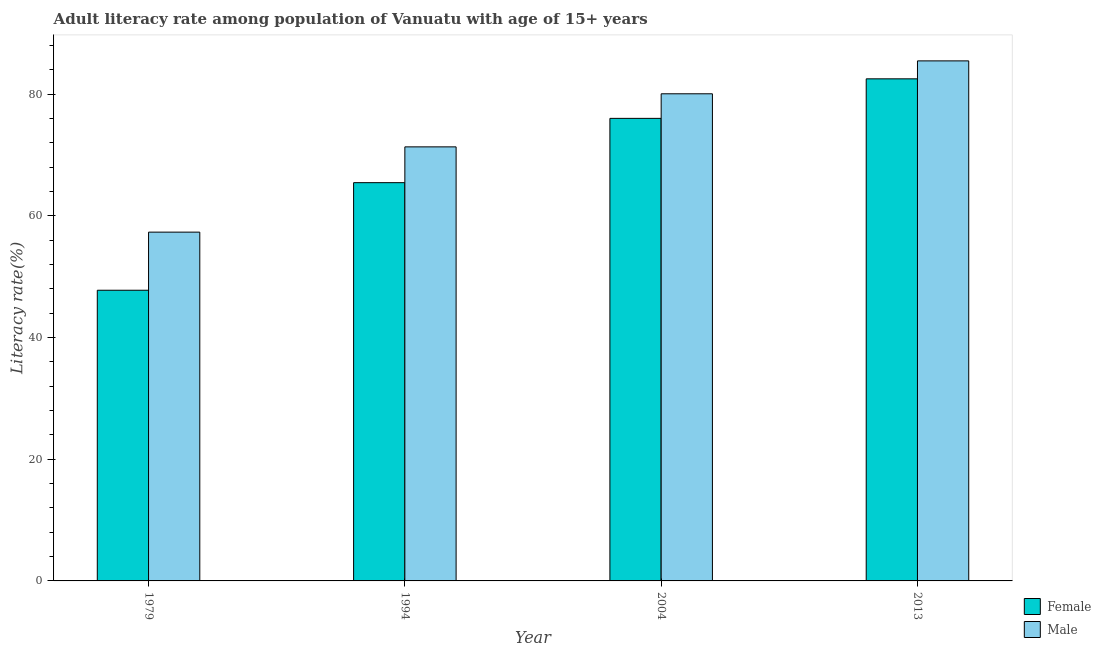How many different coloured bars are there?
Give a very brief answer. 2. How many groups of bars are there?
Your answer should be compact. 4. How many bars are there on the 4th tick from the left?
Your answer should be very brief. 2. What is the label of the 4th group of bars from the left?
Make the answer very short. 2013. What is the female adult literacy rate in 2004?
Provide a short and direct response. 76.03. Across all years, what is the maximum male adult literacy rate?
Offer a terse response. 85.49. Across all years, what is the minimum male adult literacy rate?
Give a very brief answer. 57.34. In which year was the male adult literacy rate minimum?
Give a very brief answer. 1979. What is the total male adult literacy rate in the graph?
Your answer should be very brief. 294.25. What is the difference between the female adult literacy rate in 1979 and that in 2004?
Offer a terse response. -28.25. What is the difference between the female adult literacy rate in 1994 and the male adult literacy rate in 2013?
Ensure brevity in your answer.  -17.07. What is the average female adult literacy rate per year?
Your answer should be compact. 67.95. In the year 2013, what is the difference between the female adult literacy rate and male adult literacy rate?
Offer a terse response. 0. What is the ratio of the male adult literacy rate in 1979 to that in 2013?
Keep it short and to the point. 0.67. Is the difference between the female adult literacy rate in 1994 and 2004 greater than the difference between the male adult literacy rate in 1994 and 2004?
Your response must be concise. No. What is the difference between the highest and the second highest female adult literacy rate?
Your answer should be very brief. 6.5. What is the difference between the highest and the lowest female adult literacy rate?
Keep it short and to the point. 34.75. In how many years, is the female adult literacy rate greater than the average female adult literacy rate taken over all years?
Your response must be concise. 2. How many bars are there?
Ensure brevity in your answer.  8. Are all the bars in the graph horizontal?
Give a very brief answer. No. How many years are there in the graph?
Ensure brevity in your answer.  4. What is the difference between two consecutive major ticks on the Y-axis?
Your answer should be compact. 20. Does the graph contain grids?
Offer a terse response. No. Where does the legend appear in the graph?
Make the answer very short. Bottom right. How many legend labels are there?
Your answer should be very brief. 2. How are the legend labels stacked?
Your answer should be very brief. Vertical. What is the title of the graph?
Provide a succinct answer. Adult literacy rate among population of Vanuatu with age of 15+ years. What is the label or title of the Y-axis?
Your response must be concise. Literacy rate(%). What is the Literacy rate(%) in Female in 1979?
Your answer should be compact. 47.78. What is the Literacy rate(%) in Male in 1979?
Give a very brief answer. 57.34. What is the Literacy rate(%) in Female in 1994?
Your answer should be compact. 65.47. What is the Literacy rate(%) of Male in 1994?
Provide a succinct answer. 71.35. What is the Literacy rate(%) in Female in 2004?
Give a very brief answer. 76.03. What is the Literacy rate(%) in Male in 2004?
Offer a very short reply. 80.07. What is the Literacy rate(%) in Female in 2013?
Ensure brevity in your answer.  82.53. What is the Literacy rate(%) of Male in 2013?
Offer a terse response. 85.49. Across all years, what is the maximum Literacy rate(%) of Female?
Ensure brevity in your answer.  82.53. Across all years, what is the maximum Literacy rate(%) in Male?
Ensure brevity in your answer.  85.49. Across all years, what is the minimum Literacy rate(%) in Female?
Provide a succinct answer. 47.78. Across all years, what is the minimum Literacy rate(%) in Male?
Your answer should be compact. 57.34. What is the total Literacy rate(%) in Female in the graph?
Give a very brief answer. 271.82. What is the total Literacy rate(%) in Male in the graph?
Provide a short and direct response. 294.25. What is the difference between the Literacy rate(%) of Female in 1979 and that in 1994?
Keep it short and to the point. -17.68. What is the difference between the Literacy rate(%) of Male in 1979 and that in 1994?
Make the answer very short. -14.02. What is the difference between the Literacy rate(%) in Female in 1979 and that in 2004?
Provide a succinct answer. -28.25. What is the difference between the Literacy rate(%) in Male in 1979 and that in 2004?
Give a very brief answer. -22.74. What is the difference between the Literacy rate(%) of Female in 1979 and that in 2013?
Offer a terse response. -34.75. What is the difference between the Literacy rate(%) in Male in 1979 and that in 2013?
Keep it short and to the point. -28.15. What is the difference between the Literacy rate(%) in Female in 1994 and that in 2004?
Provide a short and direct response. -10.57. What is the difference between the Literacy rate(%) of Male in 1994 and that in 2004?
Make the answer very short. -8.72. What is the difference between the Literacy rate(%) of Female in 1994 and that in 2013?
Provide a short and direct response. -17.07. What is the difference between the Literacy rate(%) of Male in 1994 and that in 2013?
Give a very brief answer. -14.13. What is the difference between the Literacy rate(%) in Female in 2004 and that in 2013?
Ensure brevity in your answer.  -6.5. What is the difference between the Literacy rate(%) in Male in 2004 and that in 2013?
Your answer should be very brief. -5.41. What is the difference between the Literacy rate(%) of Female in 1979 and the Literacy rate(%) of Male in 1994?
Give a very brief answer. -23.57. What is the difference between the Literacy rate(%) of Female in 1979 and the Literacy rate(%) of Male in 2004?
Ensure brevity in your answer.  -32.29. What is the difference between the Literacy rate(%) of Female in 1979 and the Literacy rate(%) of Male in 2013?
Your answer should be compact. -37.7. What is the difference between the Literacy rate(%) in Female in 1994 and the Literacy rate(%) in Male in 2004?
Offer a terse response. -14.61. What is the difference between the Literacy rate(%) in Female in 1994 and the Literacy rate(%) in Male in 2013?
Your answer should be very brief. -20.02. What is the difference between the Literacy rate(%) of Female in 2004 and the Literacy rate(%) of Male in 2013?
Your response must be concise. -9.45. What is the average Literacy rate(%) of Female per year?
Offer a very short reply. 67.95. What is the average Literacy rate(%) in Male per year?
Provide a short and direct response. 73.56. In the year 1979, what is the difference between the Literacy rate(%) in Female and Literacy rate(%) in Male?
Provide a succinct answer. -9.55. In the year 1994, what is the difference between the Literacy rate(%) in Female and Literacy rate(%) in Male?
Keep it short and to the point. -5.88. In the year 2004, what is the difference between the Literacy rate(%) of Female and Literacy rate(%) of Male?
Your answer should be very brief. -4.04. In the year 2013, what is the difference between the Literacy rate(%) in Female and Literacy rate(%) in Male?
Ensure brevity in your answer.  -2.95. What is the ratio of the Literacy rate(%) in Female in 1979 to that in 1994?
Provide a short and direct response. 0.73. What is the ratio of the Literacy rate(%) of Male in 1979 to that in 1994?
Offer a terse response. 0.8. What is the ratio of the Literacy rate(%) in Female in 1979 to that in 2004?
Provide a succinct answer. 0.63. What is the ratio of the Literacy rate(%) of Male in 1979 to that in 2004?
Provide a short and direct response. 0.72. What is the ratio of the Literacy rate(%) in Female in 1979 to that in 2013?
Make the answer very short. 0.58. What is the ratio of the Literacy rate(%) of Male in 1979 to that in 2013?
Offer a very short reply. 0.67. What is the ratio of the Literacy rate(%) of Female in 1994 to that in 2004?
Ensure brevity in your answer.  0.86. What is the ratio of the Literacy rate(%) in Male in 1994 to that in 2004?
Your answer should be compact. 0.89. What is the ratio of the Literacy rate(%) of Female in 1994 to that in 2013?
Offer a terse response. 0.79. What is the ratio of the Literacy rate(%) of Male in 1994 to that in 2013?
Your response must be concise. 0.83. What is the ratio of the Literacy rate(%) of Female in 2004 to that in 2013?
Your answer should be very brief. 0.92. What is the ratio of the Literacy rate(%) in Male in 2004 to that in 2013?
Give a very brief answer. 0.94. What is the difference between the highest and the second highest Literacy rate(%) of Female?
Make the answer very short. 6.5. What is the difference between the highest and the second highest Literacy rate(%) in Male?
Ensure brevity in your answer.  5.41. What is the difference between the highest and the lowest Literacy rate(%) in Female?
Give a very brief answer. 34.75. What is the difference between the highest and the lowest Literacy rate(%) in Male?
Offer a terse response. 28.15. 